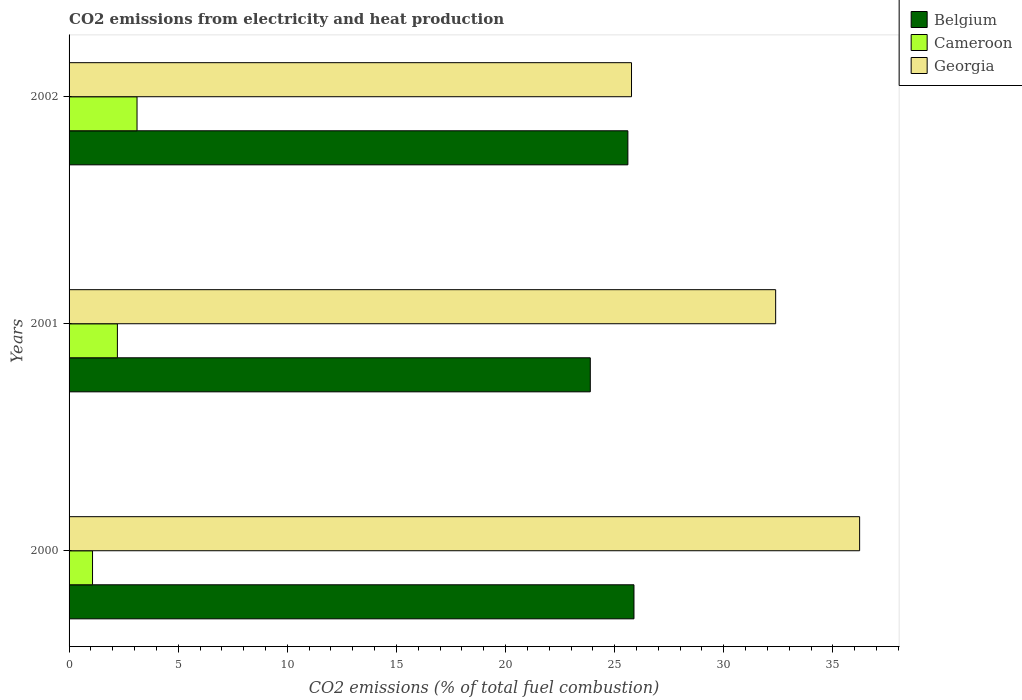Are the number of bars per tick equal to the number of legend labels?
Ensure brevity in your answer.  Yes. Are the number of bars on each tick of the Y-axis equal?
Give a very brief answer. Yes. What is the label of the 2nd group of bars from the top?
Your answer should be compact. 2001. What is the amount of CO2 emitted in Cameroon in 2002?
Keep it short and to the point. 3.11. Across all years, what is the maximum amount of CO2 emitted in Cameroon?
Keep it short and to the point. 3.11. Across all years, what is the minimum amount of CO2 emitted in Belgium?
Provide a succinct answer. 23.88. What is the total amount of CO2 emitted in Georgia in the graph?
Your answer should be compact. 94.38. What is the difference between the amount of CO2 emitted in Georgia in 2000 and that in 2001?
Your response must be concise. 3.85. What is the difference between the amount of CO2 emitted in Georgia in 2000 and the amount of CO2 emitted in Cameroon in 2001?
Provide a succinct answer. 34.01. What is the average amount of CO2 emitted in Georgia per year?
Your answer should be compact. 31.46. In the year 2002, what is the difference between the amount of CO2 emitted in Belgium and amount of CO2 emitted in Cameroon?
Make the answer very short. 22.49. In how many years, is the amount of CO2 emitted in Georgia greater than 11 %?
Offer a terse response. 3. What is the ratio of the amount of CO2 emitted in Cameroon in 2000 to that in 2002?
Give a very brief answer. 0.35. Is the difference between the amount of CO2 emitted in Belgium in 2001 and 2002 greater than the difference between the amount of CO2 emitted in Cameroon in 2001 and 2002?
Provide a short and direct response. No. What is the difference between the highest and the second highest amount of CO2 emitted in Georgia?
Offer a very short reply. 3.85. What is the difference between the highest and the lowest amount of CO2 emitted in Belgium?
Give a very brief answer. 2. In how many years, is the amount of CO2 emitted in Belgium greater than the average amount of CO2 emitted in Belgium taken over all years?
Your answer should be compact. 2. What does the 3rd bar from the top in 2002 represents?
Ensure brevity in your answer.  Belgium. What does the 3rd bar from the bottom in 2001 represents?
Your answer should be compact. Georgia. Is it the case that in every year, the sum of the amount of CO2 emitted in Belgium and amount of CO2 emitted in Cameroon is greater than the amount of CO2 emitted in Georgia?
Keep it short and to the point. No. How many bars are there?
Make the answer very short. 9. Are all the bars in the graph horizontal?
Provide a succinct answer. Yes. How many years are there in the graph?
Keep it short and to the point. 3. Are the values on the major ticks of X-axis written in scientific E-notation?
Offer a very short reply. No. Does the graph contain any zero values?
Make the answer very short. No. Where does the legend appear in the graph?
Make the answer very short. Top right. How many legend labels are there?
Ensure brevity in your answer.  3. How are the legend labels stacked?
Your response must be concise. Vertical. What is the title of the graph?
Provide a succinct answer. CO2 emissions from electricity and heat production. Does "Guatemala" appear as one of the legend labels in the graph?
Provide a short and direct response. No. What is the label or title of the X-axis?
Give a very brief answer. CO2 emissions (% of total fuel combustion). What is the CO2 emissions (% of total fuel combustion) of Belgium in 2000?
Provide a succinct answer. 25.89. What is the CO2 emissions (% of total fuel combustion) of Cameroon in 2000?
Give a very brief answer. 1.08. What is the CO2 emissions (% of total fuel combustion) in Georgia in 2000?
Keep it short and to the point. 36.23. What is the CO2 emissions (% of total fuel combustion) of Belgium in 2001?
Provide a succinct answer. 23.88. What is the CO2 emissions (% of total fuel combustion) of Cameroon in 2001?
Offer a very short reply. 2.21. What is the CO2 emissions (% of total fuel combustion) of Georgia in 2001?
Ensure brevity in your answer.  32.38. What is the CO2 emissions (% of total fuel combustion) of Belgium in 2002?
Ensure brevity in your answer.  25.61. What is the CO2 emissions (% of total fuel combustion) of Cameroon in 2002?
Offer a very short reply. 3.11. What is the CO2 emissions (% of total fuel combustion) in Georgia in 2002?
Provide a short and direct response. 25.77. Across all years, what is the maximum CO2 emissions (% of total fuel combustion) in Belgium?
Offer a terse response. 25.89. Across all years, what is the maximum CO2 emissions (% of total fuel combustion) of Cameroon?
Your answer should be very brief. 3.11. Across all years, what is the maximum CO2 emissions (% of total fuel combustion) of Georgia?
Your answer should be compact. 36.23. Across all years, what is the minimum CO2 emissions (% of total fuel combustion) of Belgium?
Your answer should be compact. 23.88. Across all years, what is the minimum CO2 emissions (% of total fuel combustion) of Cameroon?
Your answer should be very brief. 1.08. Across all years, what is the minimum CO2 emissions (% of total fuel combustion) in Georgia?
Offer a terse response. 25.77. What is the total CO2 emissions (% of total fuel combustion) of Belgium in the graph?
Make the answer very short. 75.38. What is the total CO2 emissions (% of total fuel combustion) in Cameroon in the graph?
Your answer should be compact. 6.4. What is the total CO2 emissions (% of total fuel combustion) of Georgia in the graph?
Provide a short and direct response. 94.38. What is the difference between the CO2 emissions (% of total fuel combustion) in Belgium in 2000 and that in 2001?
Provide a short and direct response. 2. What is the difference between the CO2 emissions (% of total fuel combustion) in Cameroon in 2000 and that in 2001?
Your answer should be very brief. -1.14. What is the difference between the CO2 emissions (% of total fuel combustion) in Georgia in 2000 and that in 2001?
Keep it short and to the point. 3.85. What is the difference between the CO2 emissions (% of total fuel combustion) of Belgium in 2000 and that in 2002?
Make the answer very short. 0.28. What is the difference between the CO2 emissions (% of total fuel combustion) of Cameroon in 2000 and that in 2002?
Your answer should be very brief. -2.04. What is the difference between the CO2 emissions (% of total fuel combustion) of Georgia in 2000 and that in 2002?
Offer a terse response. 10.45. What is the difference between the CO2 emissions (% of total fuel combustion) in Belgium in 2001 and that in 2002?
Offer a terse response. -1.72. What is the difference between the CO2 emissions (% of total fuel combustion) in Cameroon in 2001 and that in 2002?
Your response must be concise. -0.9. What is the difference between the CO2 emissions (% of total fuel combustion) in Georgia in 2001 and that in 2002?
Your answer should be very brief. 6.61. What is the difference between the CO2 emissions (% of total fuel combustion) of Belgium in 2000 and the CO2 emissions (% of total fuel combustion) of Cameroon in 2001?
Provide a succinct answer. 23.67. What is the difference between the CO2 emissions (% of total fuel combustion) in Belgium in 2000 and the CO2 emissions (% of total fuel combustion) in Georgia in 2001?
Your answer should be very brief. -6.49. What is the difference between the CO2 emissions (% of total fuel combustion) of Cameroon in 2000 and the CO2 emissions (% of total fuel combustion) of Georgia in 2001?
Provide a succinct answer. -31.3. What is the difference between the CO2 emissions (% of total fuel combustion) in Belgium in 2000 and the CO2 emissions (% of total fuel combustion) in Cameroon in 2002?
Offer a terse response. 22.77. What is the difference between the CO2 emissions (% of total fuel combustion) of Belgium in 2000 and the CO2 emissions (% of total fuel combustion) of Georgia in 2002?
Give a very brief answer. 0.11. What is the difference between the CO2 emissions (% of total fuel combustion) in Cameroon in 2000 and the CO2 emissions (% of total fuel combustion) in Georgia in 2002?
Provide a succinct answer. -24.7. What is the difference between the CO2 emissions (% of total fuel combustion) in Belgium in 2001 and the CO2 emissions (% of total fuel combustion) in Cameroon in 2002?
Ensure brevity in your answer.  20.77. What is the difference between the CO2 emissions (% of total fuel combustion) in Belgium in 2001 and the CO2 emissions (% of total fuel combustion) in Georgia in 2002?
Make the answer very short. -1.89. What is the difference between the CO2 emissions (% of total fuel combustion) in Cameroon in 2001 and the CO2 emissions (% of total fuel combustion) in Georgia in 2002?
Your answer should be very brief. -23.56. What is the average CO2 emissions (% of total fuel combustion) in Belgium per year?
Make the answer very short. 25.13. What is the average CO2 emissions (% of total fuel combustion) in Cameroon per year?
Your response must be concise. 2.13. What is the average CO2 emissions (% of total fuel combustion) in Georgia per year?
Offer a terse response. 31.46. In the year 2000, what is the difference between the CO2 emissions (% of total fuel combustion) of Belgium and CO2 emissions (% of total fuel combustion) of Cameroon?
Provide a succinct answer. 24.81. In the year 2000, what is the difference between the CO2 emissions (% of total fuel combustion) of Belgium and CO2 emissions (% of total fuel combustion) of Georgia?
Offer a terse response. -10.34. In the year 2000, what is the difference between the CO2 emissions (% of total fuel combustion) of Cameroon and CO2 emissions (% of total fuel combustion) of Georgia?
Ensure brevity in your answer.  -35.15. In the year 2001, what is the difference between the CO2 emissions (% of total fuel combustion) of Belgium and CO2 emissions (% of total fuel combustion) of Cameroon?
Your answer should be compact. 21.67. In the year 2001, what is the difference between the CO2 emissions (% of total fuel combustion) in Belgium and CO2 emissions (% of total fuel combustion) in Georgia?
Offer a very short reply. -8.49. In the year 2001, what is the difference between the CO2 emissions (% of total fuel combustion) in Cameroon and CO2 emissions (% of total fuel combustion) in Georgia?
Your response must be concise. -30.16. In the year 2002, what is the difference between the CO2 emissions (% of total fuel combustion) in Belgium and CO2 emissions (% of total fuel combustion) in Cameroon?
Make the answer very short. 22.49. In the year 2002, what is the difference between the CO2 emissions (% of total fuel combustion) of Belgium and CO2 emissions (% of total fuel combustion) of Georgia?
Keep it short and to the point. -0.17. In the year 2002, what is the difference between the CO2 emissions (% of total fuel combustion) in Cameroon and CO2 emissions (% of total fuel combustion) in Georgia?
Your answer should be very brief. -22.66. What is the ratio of the CO2 emissions (% of total fuel combustion) in Belgium in 2000 to that in 2001?
Your response must be concise. 1.08. What is the ratio of the CO2 emissions (% of total fuel combustion) of Cameroon in 2000 to that in 2001?
Offer a very short reply. 0.49. What is the ratio of the CO2 emissions (% of total fuel combustion) in Georgia in 2000 to that in 2001?
Provide a succinct answer. 1.12. What is the ratio of the CO2 emissions (% of total fuel combustion) of Belgium in 2000 to that in 2002?
Provide a succinct answer. 1.01. What is the ratio of the CO2 emissions (% of total fuel combustion) of Cameroon in 2000 to that in 2002?
Your answer should be very brief. 0.35. What is the ratio of the CO2 emissions (% of total fuel combustion) in Georgia in 2000 to that in 2002?
Make the answer very short. 1.41. What is the ratio of the CO2 emissions (% of total fuel combustion) of Belgium in 2001 to that in 2002?
Your response must be concise. 0.93. What is the ratio of the CO2 emissions (% of total fuel combustion) of Cameroon in 2001 to that in 2002?
Make the answer very short. 0.71. What is the ratio of the CO2 emissions (% of total fuel combustion) of Georgia in 2001 to that in 2002?
Your answer should be compact. 1.26. What is the difference between the highest and the second highest CO2 emissions (% of total fuel combustion) in Belgium?
Provide a short and direct response. 0.28. What is the difference between the highest and the second highest CO2 emissions (% of total fuel combustion) of Cameroon?
Offer a very short reply. 0.9. What is the difference between the highest and the second highest CO2 emissions (% of total fuel combustion) of Georgia?
Ensure brevity in your answer.  3.85. What is the difference between the highest and the lowest CO2 emissions (% of total fuel combustion) of Belgium?
Give a very brief answer. 2. What is the difference between the highest and the lowest CO2 emissions (% of total fuel combustion) in Cameroon?
Provide a short and direct response. 2.04. What is the difference between the highest and the lowest CO2 emissions (% of total fuel combustion) of Georgia?
Provide a short and direct response. 10.45. 